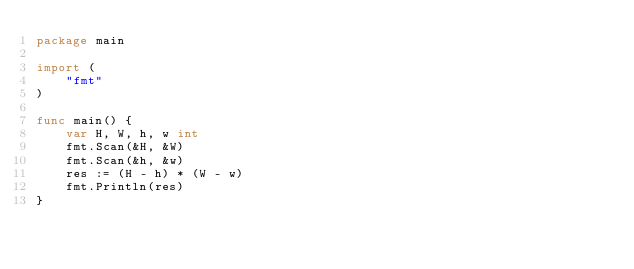<code> <loc_0><loc_0><loc_500><loc_500><_Go_>package main
  
import (
    "fmt"
)

func main() {
    var H, W, h, w int
    fmt.Scan(&H, &W)
    fmt.Scan(&h, &w)
    res := (H - h) * (W - w)
    fmt.Println(res)
}
</code> 